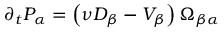<formula> <loc_0><loc_0><loc_500><loc_500>\partial _ { t } P _ { \alpha } = \left ( \nu D _ { \beta } - V _ { \beta } \right ) \Omega _ { \beta \alpha }</formula> 